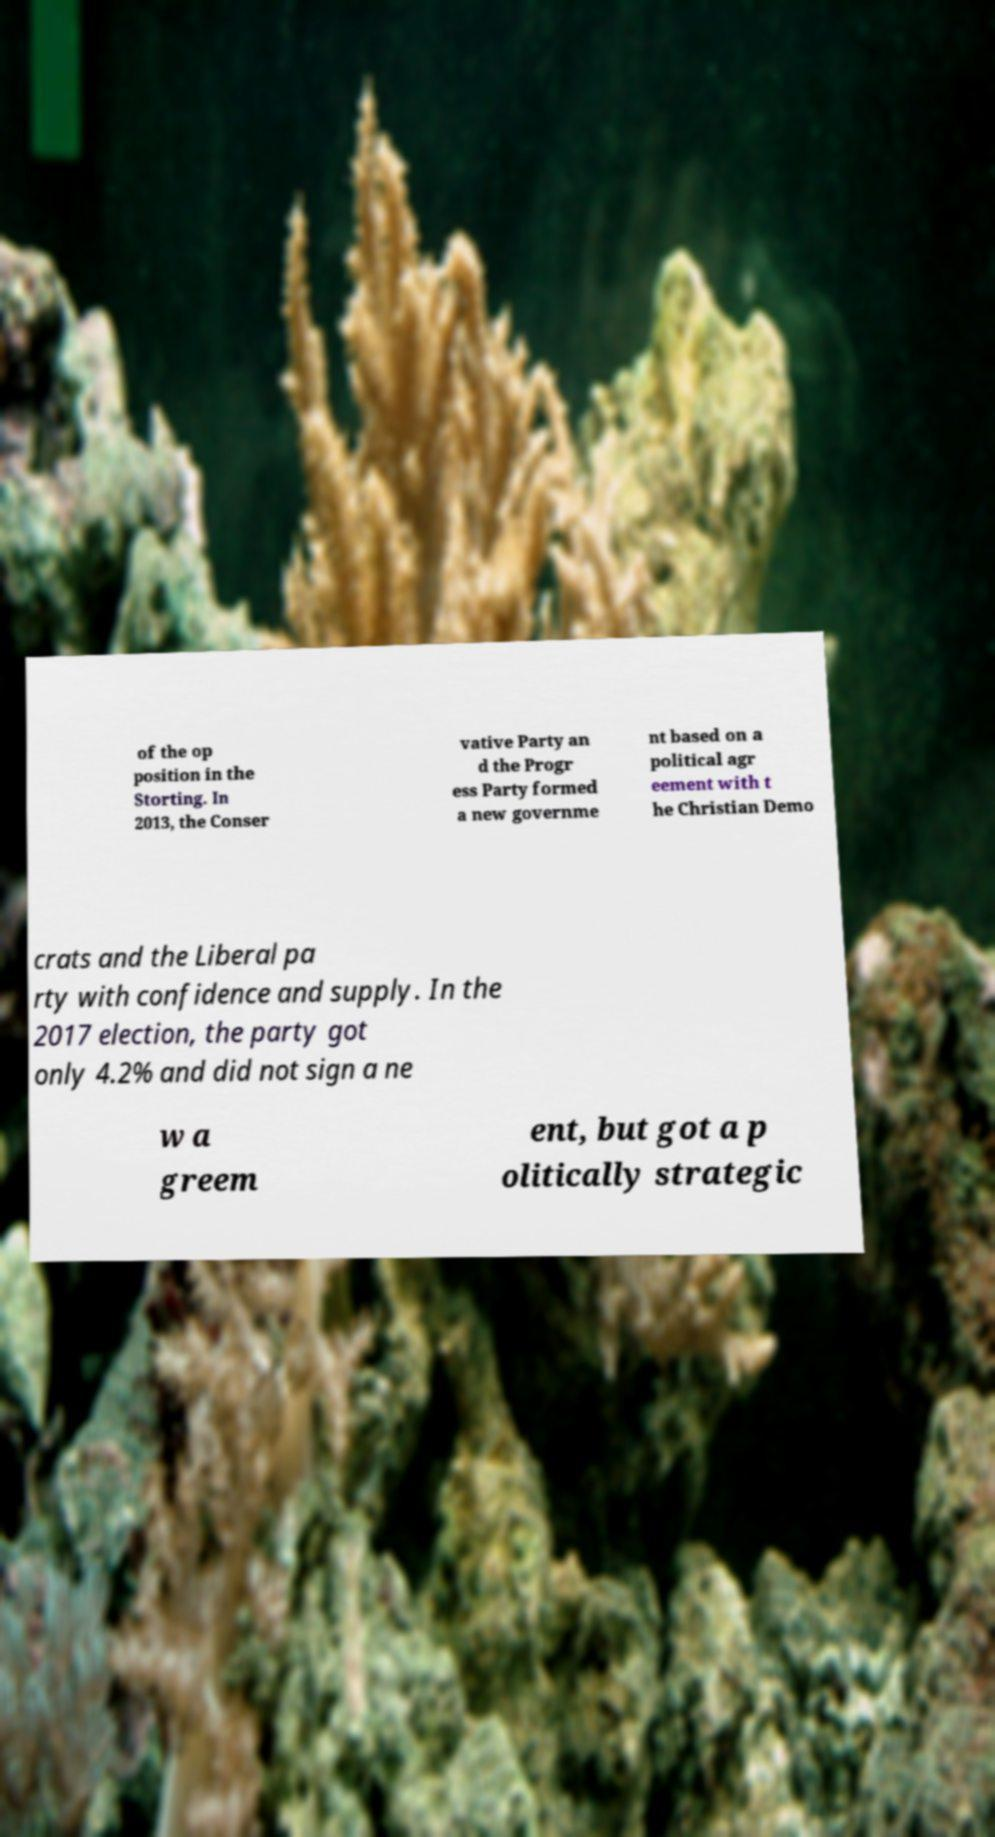For documentation purposes, I need the text within this image transcribed. Could you provide that? of the op position in the Storting. In 2013, the Conser vative Party an d the Progr ess Party formed a new governme nt based on a political agr eement with t he Christian Demo crats and the Liberal pa rty with confidence and supply. In the 2017 election, the party got only 4.2% and did not sign a ne w a greem ent, but got a p olitically strategic 